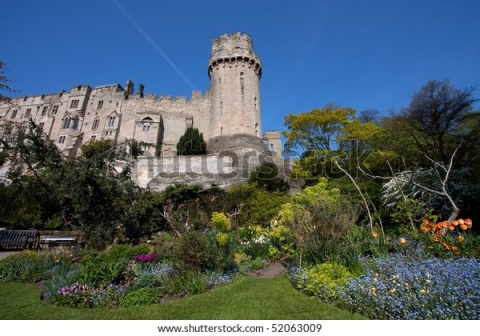Provide a historical context and likely restoration efforts for the castle and its surroundings. The castle, standing as a testament to medieval architecture, has likely witnessed numerous historical events and transitions. Originally constructed in the 12th century, it served as a fortress during times of conflict and as a noble residence during periods of peace. Throughout the centuries, the castle underwent various expansions and modifications, each adding to its grandeur and historical significance.

During the Renaissance, the castle was beautifully adorned with artistic elements, while the surrounding garden was designed following the era’s emphasis on symmetry and natural beauty. In the 19th century, the castle may have faced neglect, resulting in considerable wear. However, recognizing its cultural and historical value, local heritage societies embarked on extensive restoration efforts in the early 20th century.

These restoration efforts focused on meticulously preserving the original stonework while restoring damaged sections with materials matching the medieval construction. The garden was revived following historical records and botanical studies, reintroducing native plant species and enhancing the landscape’s aesthetic appeal. Today, the castle and its garden stand as beautifully restored landmarks, offering a glimpse into a bygone era while serving as a serene sanctuary for visitors.  Describe the experience of a visitor exploring this castle and garden. Visiting the castle is a journey through time. As you approach the imposing gray stone structure, the tall tower catches your eye, beckoning you to discover its secrets. Stepping through the grand entrance, you are immediately immersed in history, with walls adorned with tapestries and corridors echoing tales of old. The rooms within the castle range from grand halls with towering ceilings to cozy chambers with intricate woodwork, each offering a unique glimpse into the lives of the castle’s former inhabitants.

After exploring the interior, you step into the castle's garden, greeted by a burst of colors and the delicate fragrance of blooming flowers. The meticulously tended beds boast a variety of plants, from vibrant orange tulips to delicate blue forget-me-nots. Walking along the winding paths, you find a wooden bench inviting you to sit and soak in the tranquil beauty. Birds chirp in the background, and the gentle rustling of leaves adds to the serene atmosphere.

The experience is both educational and deeply relaxing, providing insight into the historical significance of the castle while allowing you to enjoy the natural splendor of the garden. Visitors often leave with a sense of awe, marveling at the harmonious blend of history, architecture, and nature. 